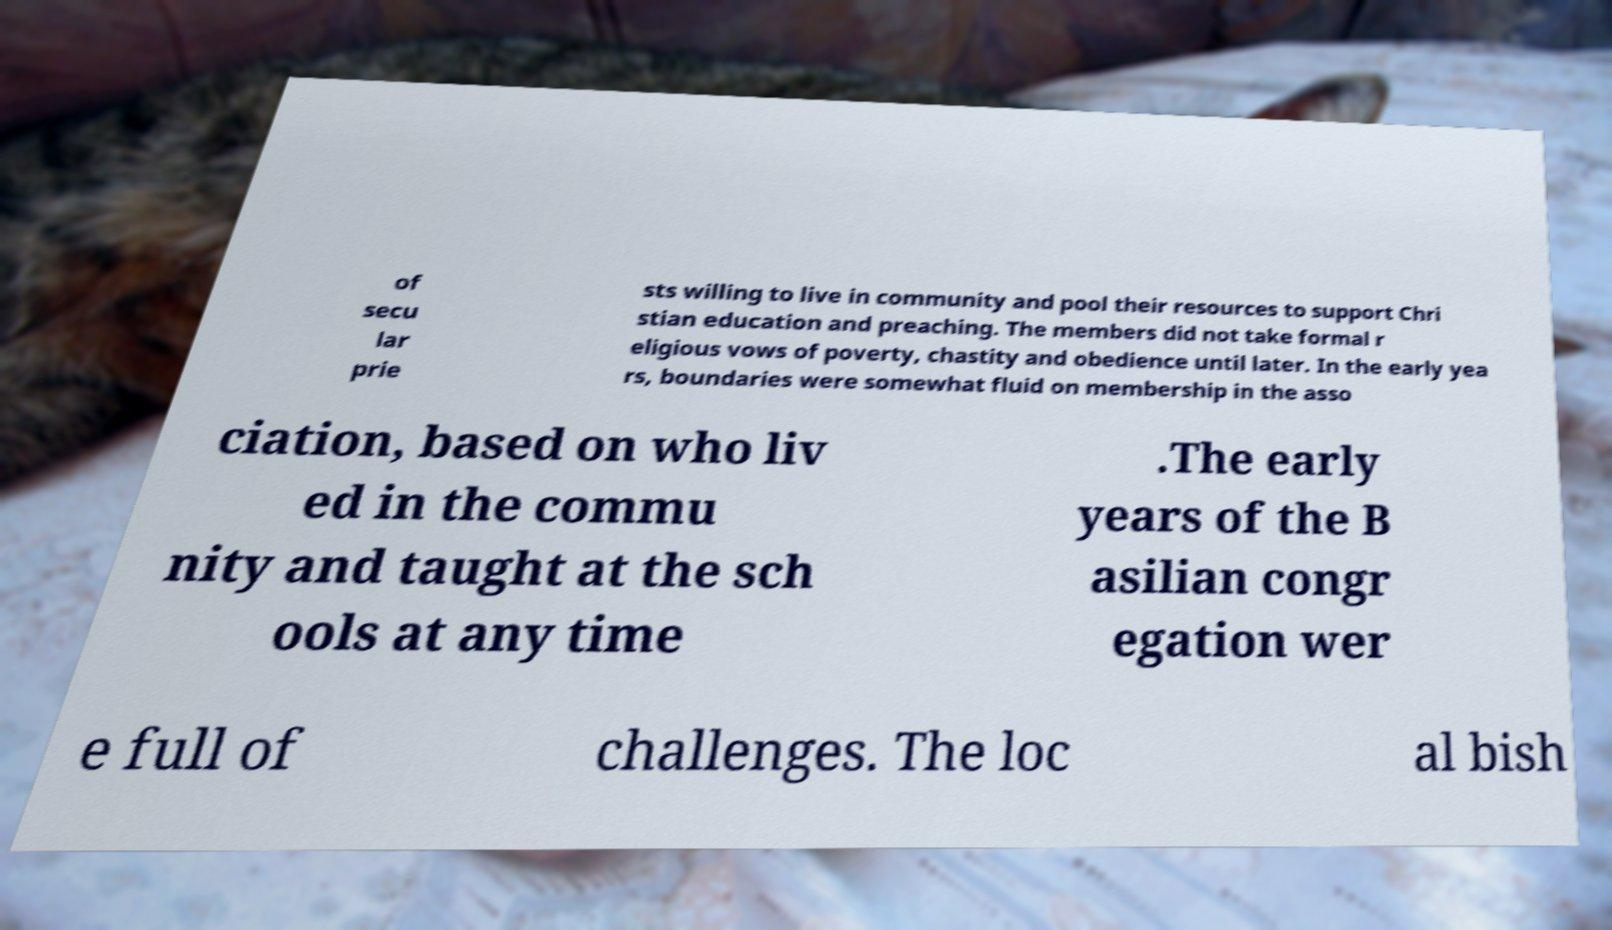Could you assist in decoding the text presented in this image and type it out clearly? of secu lar prie sts willing to live in community and pool their resources to support Chri stian education and preaching. The members did not take formal r eligious vows of poverty, chastity and obedience until later. In the early yea rs, boundaries were somewhat fluid on membership in the asso ciation, based on who liv ed in the commu nity and taught at the sch ools at any time .The early years of the B asilian congr egation wer e full of challenges. The loc al bish 